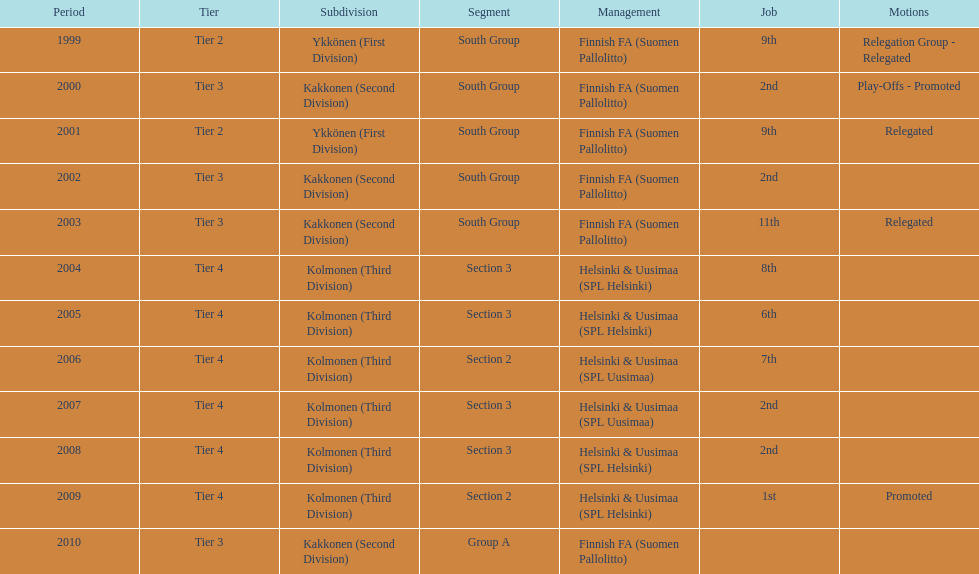Which administration has the least amount of division? Helsinki & Uusimaa (SPL Helsinki). 